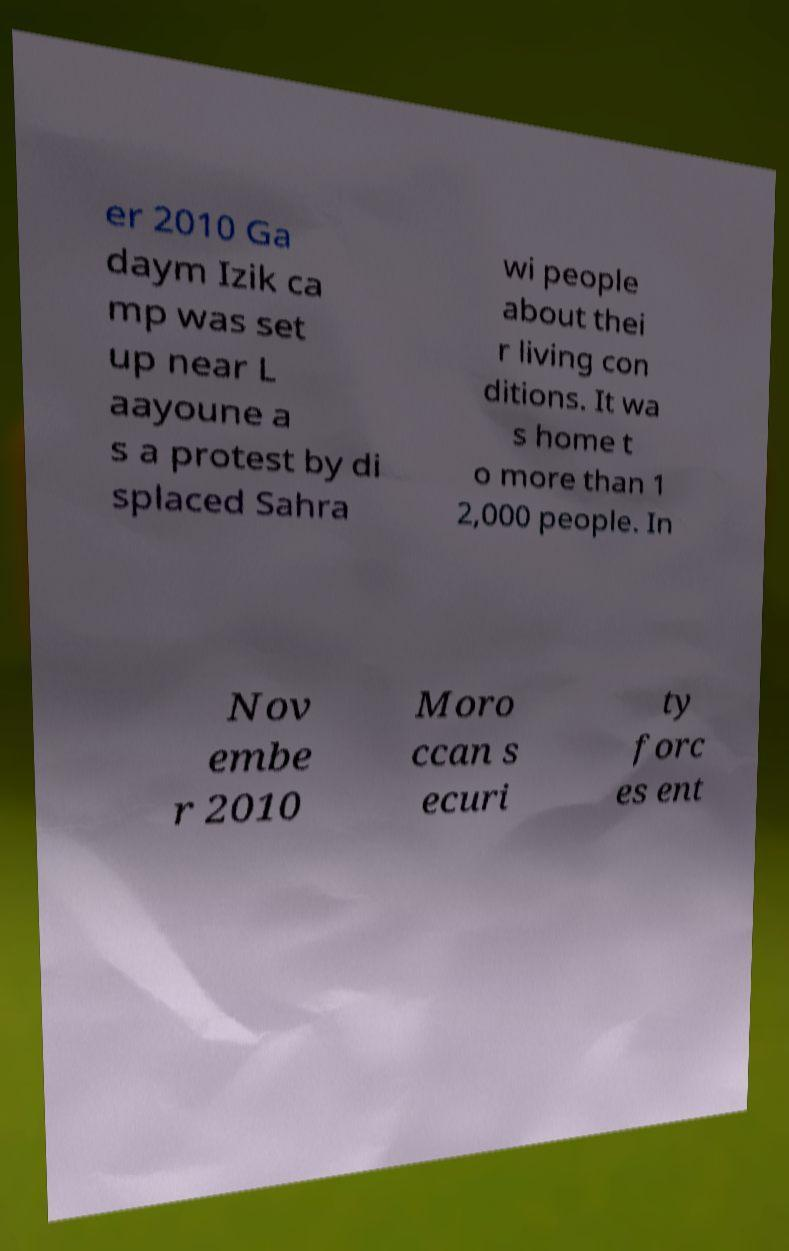For documentation purposes, I need the text within this image transcribed. Could you provide that? er 2010 Ga daym Izik ca mp was set up near L aayoune a s a protest by di splaced Sahra wi people about thei r living con ditions. It wa s home t o more than 1 2,000 people. In Nov embe r 2010 Moro ccan s ecuri ty forc es ent 